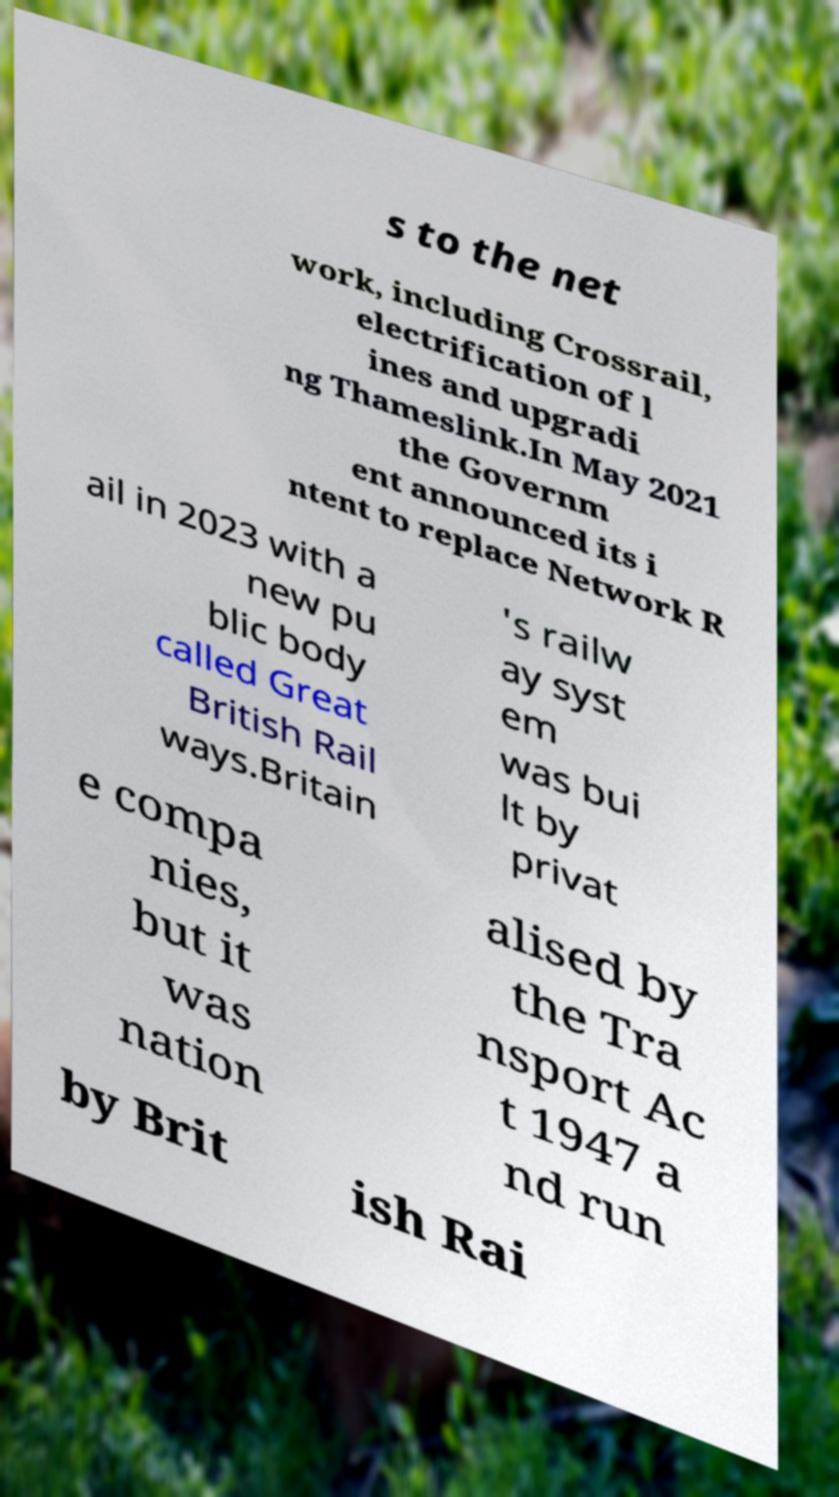What messages or text are displayed in this image? I need them in a readable, typed format. s to the net work, including Crossrail, electrification of l ines and upgradi ng Thameslink.In May 2021 the Governm ent announced its i ntent to replace Network R ail in 2023 with a new pu blic body called Great British Rail ways.Britain 's railw ay syst em was bui lt by privat e compa nies, but it was nation alised by the Tra nsport Ac t 1947 a nd run by Brit ish Rai 